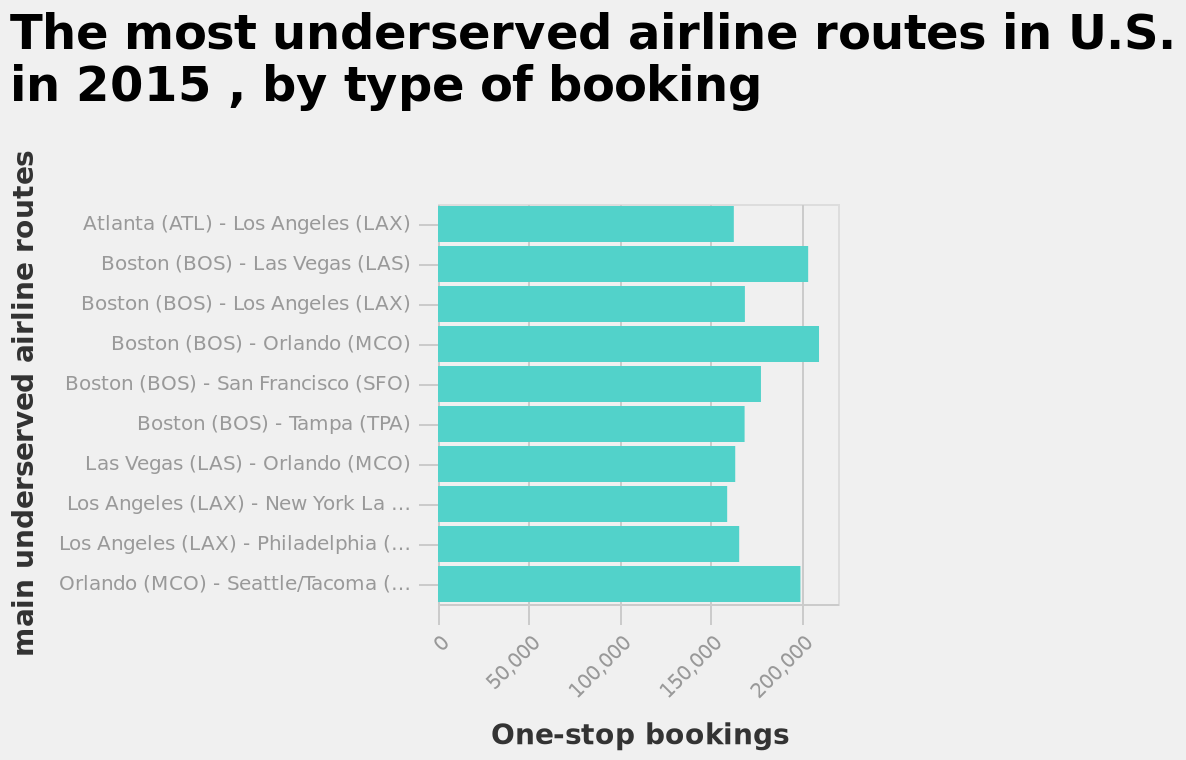<image>
What does the bar graph represent?  The bar graph represents the most underserved airline routes in the U.S. in 2015, categorized by the type of booking. please describe the details of the chart The most underserved airline routes in U.S. in 2015 , by type of booking is a bar graph. The y-axis measures main underserved airline routes while the x-axis measures One-stop bookings. 